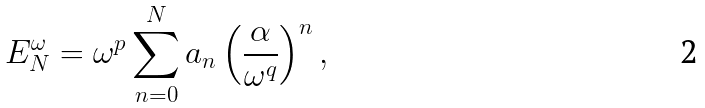Convert formula to latex. <formula><loc_0><loc_0><loc_500><loc_500>E _ { N } ^ { \omega } = \omega ^ { p } \sum _ { n = 0 } ^ { N } a _ { n } \left ( \frac { \alpha } { \omega ^ { q } } \right ) ^ { n } ,</formula> 